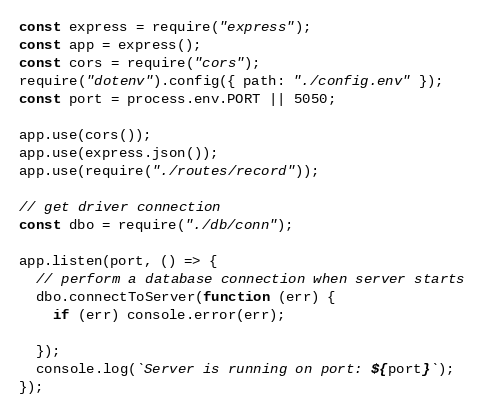<code> <loc_0><loc_0><loc_500><loc_500><_JavaScript_>const express = require("express");
const app = express();
const cors = require("cors");
require("dotenv").config({ path: "./config.env" });
const port = process.env.PORT || 5050;

app.use(cors());
app.use(express.json());
app.use(require("./routes/record"));

// get driver connection
const dbo = require("./db/conn");

app.listen(port, () => {
  // perform a database connection when server starts
  dbo.connectToServer(function (err) {
    if (err) console.error(err);

  });
  console.log(`Server is running on port: ${port}`);
});
</code> 